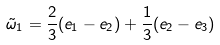Convert formula to latex. <formula><loc_0><loc_0><loc_500><loc_500>\tilde { \omega } _ { 1 } = \frac { 2 } { 3 } ( e _ { 1 } - e _ { 2 } ) + \frac { 1 } { 3 } ( e _ { 2 } - e _ { 3 } )</formula> 